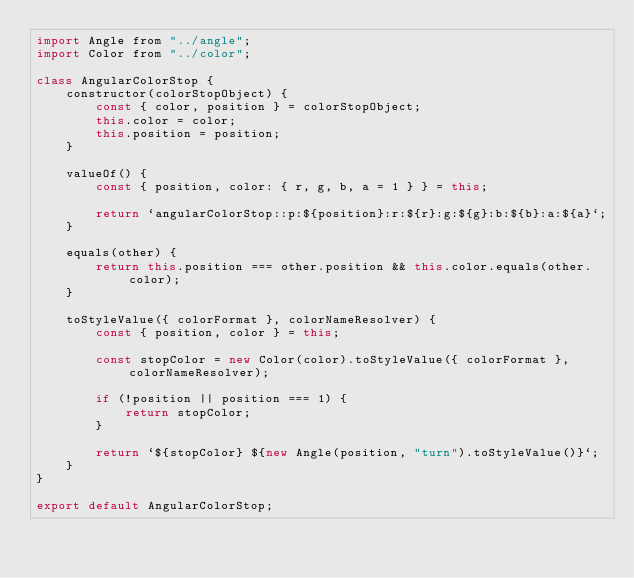Convert code to text. <code><loc_0><loc_0><loc_500><loc_500><_JavaScript_>import Angle from "../angle";
import Color from "../color";

class AngularColorStop {
    constructor(colorStopObject) {
        const { color, position } = colorStopObject;
        this.color = color;
        this.position = position;
    }

    valueOf() {
        const { position, color: { r, g, b, a = 1 } } = this;

        return `angularColorStop::p:${position}:r:${r}:g:${g}:b:${b}:a:${a}`;
    }

    equals(other) {
        return this.position === other.position && this.color.equals(other.color);
    }

    toStyleValue({ colorFormat }, colorNameResolver) {
        const { position, color } = this;

        const stopColor = new Color(color).toStyleValue({ colorFormat }, colorNameResolver);

        if (!position || position === 1) {
            return stopColor;
        }

        return `${stopColor} ${new Angle(position, "turn").toStyleValue()}`;
    }
}

export default AngularColorStop;
</code> 